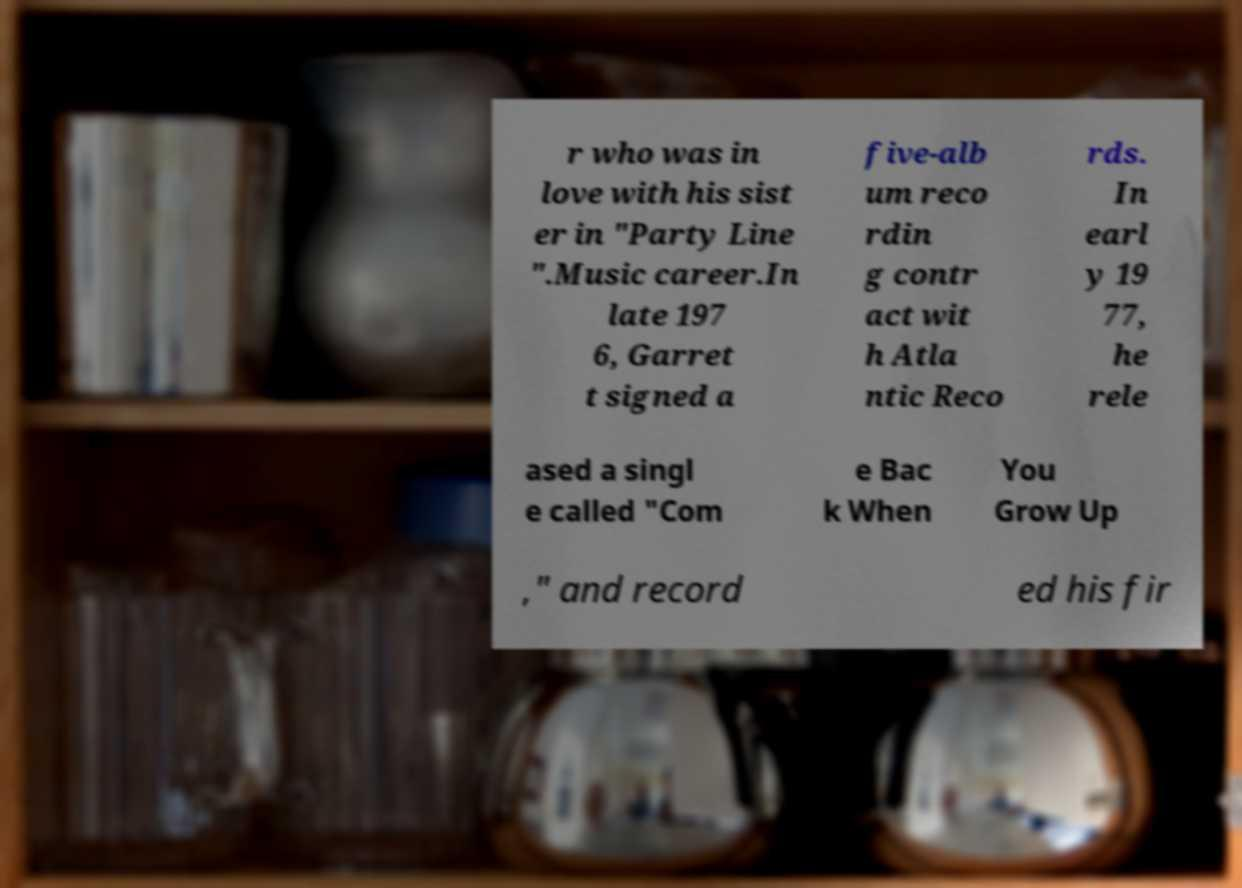Can you read and provide the text displayed in the image?This photo seems to have some interesting text. Can you extract and type it out for me? r who was in love with his sist er in "Party Line ".Music career.In late 197 6, Garret t signed a five-alb um reco rdin g contr act wit h Atla ntic Reco rds. In earl y 19 77, he rele ased a singl e called "Com e Bac k When You Grow Up ," and record ed his fir 